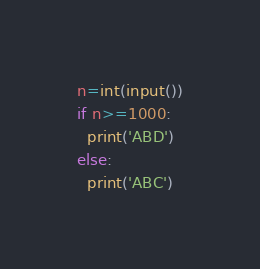Convert code to text. <code><loc_0><loc_0><loc_500><loc_500><_Python_>n=int(input())
if n>=1000:
  print('ABD')
else:
  print('ABC')</code> 